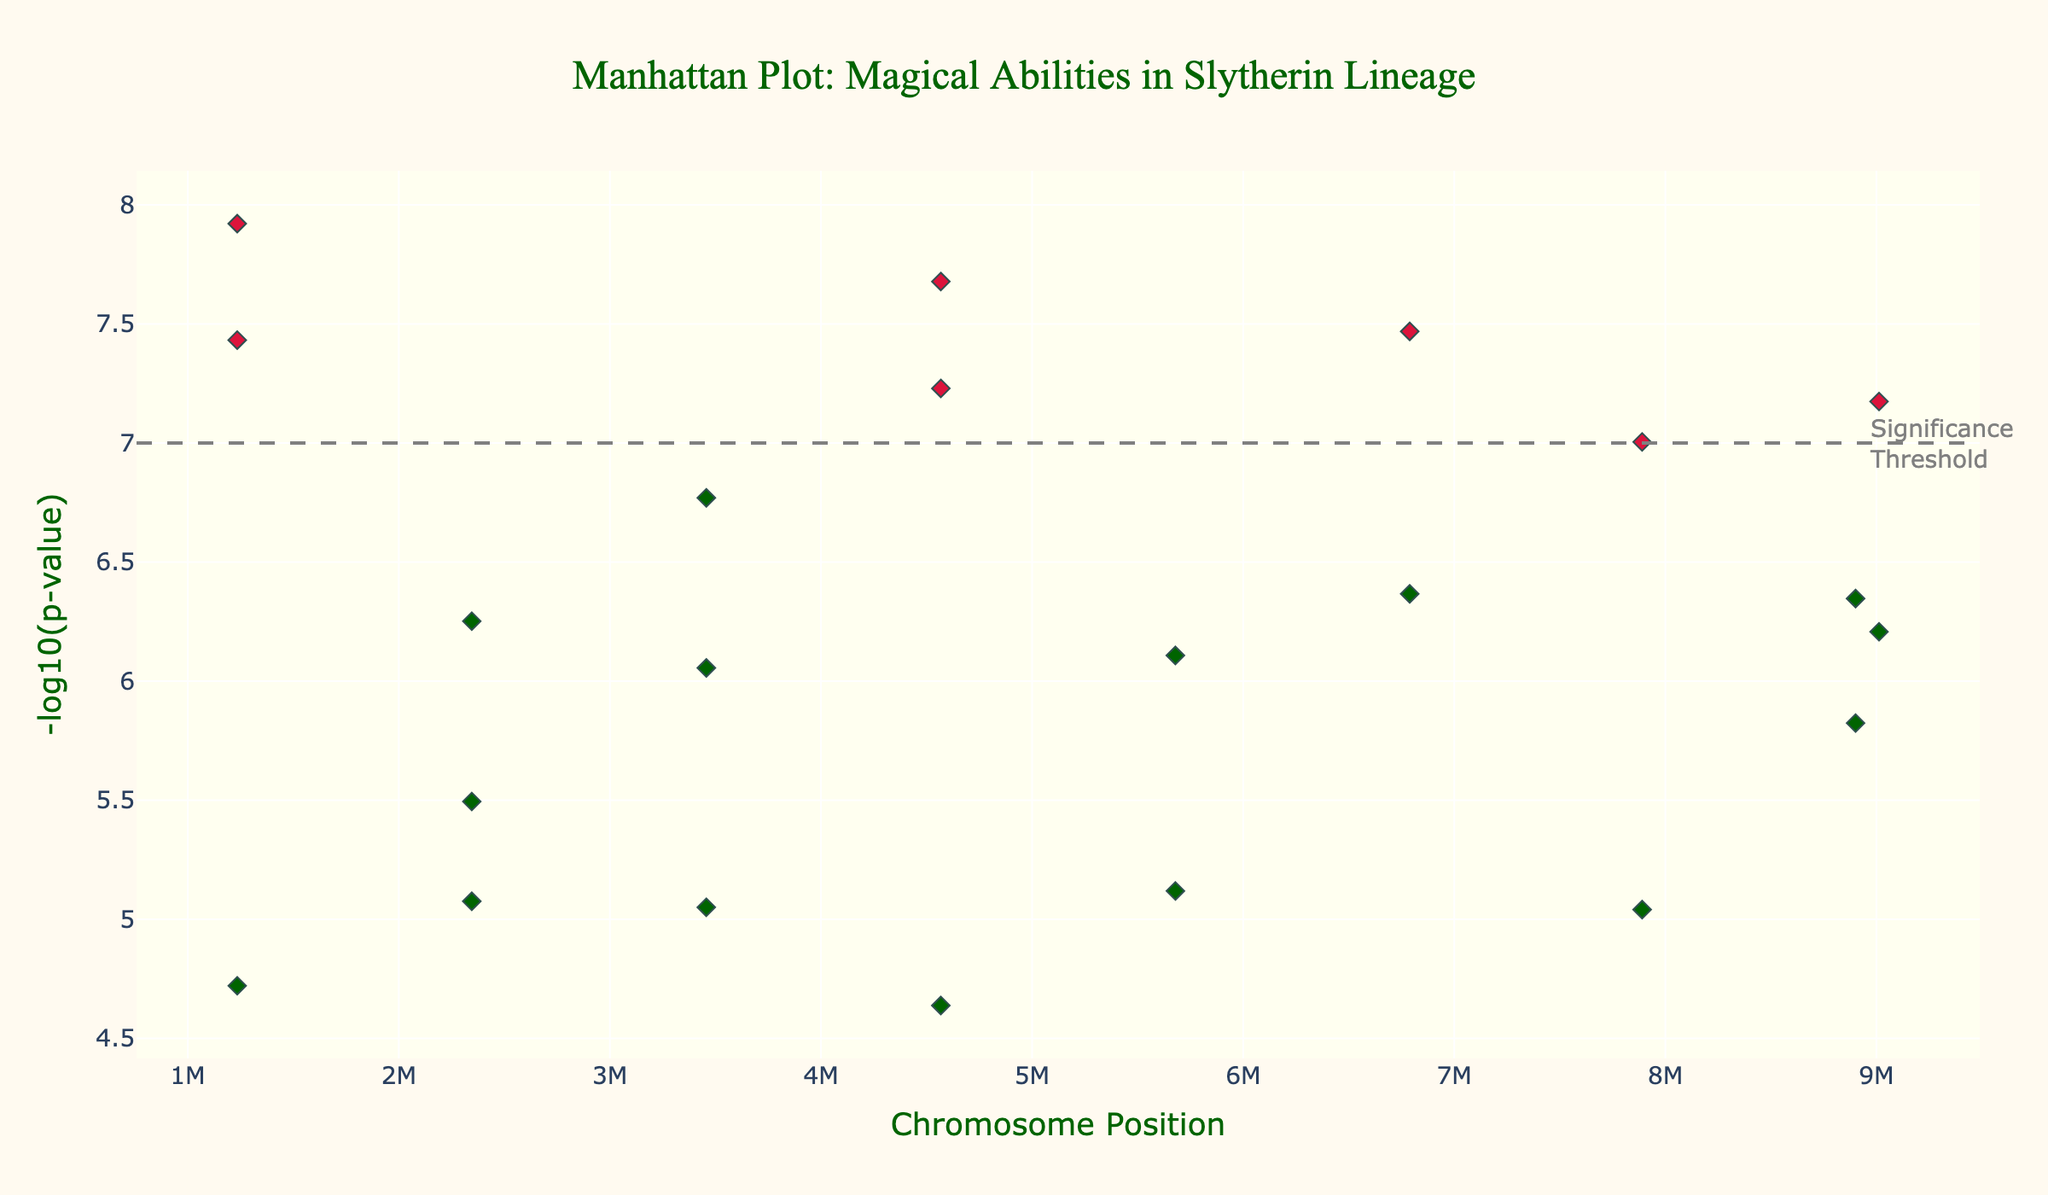What is the title of the Manhattan plot? The title of the Manhattan plot can be found at the top of the figure and usually provides a quick overview of what the plot is depicting. The title here says "Manhattan Plot: Magical Abilities in Slytherin Lineage."
Answer: Manhattan Plot: Magical Abilities in Slytherin Lineage Which chromosome has the gene associated with the highest -log10(p-value)? By looking at the y-axis, the gene with the highest -log10(p-value) value will be the highest point on the plot. The corresponding chromosome number of this point will provide the answer.
Answer: Chromosome 1 How many genes have a -log10(p-value) greater than the significance threshold (7)? Genes with -log10(p-values) greater than 7 will be the points above the horizontal dash line at y=7. Counting these points gives the number of genes over the threshold.
Answer: 7 genes What are the traits associated with the genes that have a -log10(p-value) greater than 7? The traits can be identified by hovering over the points above the significance threshold in the plot or reading from the legend if available. The traits are Parseltongue, Occlumency proficiency, Potions expertise, Memory charm resistance, Pure-blood lineage markers, Charm casting prowess, and Sorting Hat influence.
Answer: Parseltongue, Occlumency proficiency, Potions expertise, Memory charm resistance, Pure-blood lineage markers, Charm casting prowess, Sorting Hat influence Which gene and trait are associated with Chromosome 4? To find the gene and trait related to Chromosome 4, locate the data points associated with Chromosome 4 and inspect their hover text or check the legend if available. In this case, the gene is DARKARTS4 and the trait is Dark magic aptitude.
Answer: DARKARTS4, Dark magic aptitude What is the chromosomal position of the gene with the highest -log10(p-value)? The highest -log10(p-value) point on the plot indicates the gene with the highest significance. Check the x-axis value (position) where this point is located. The highest point corresponds to Chromosome 1 at position 1234567.
Answer: 1234567 Compare the -log10(p-value) of genes on Chromosome 5 and 8. Which gene has a higher value? To compare, find the -log10(p)value of the genes on Chromosome 5 and 8. Chromosome 5 has a value associated with Cunning and ambition, and Chromosome 8 with Blonde hair inheritance. The gene on Chromosome 8 has a higher -log10(p-value) based on the position within the plot.
Answer: Blonde hair inheritance How many chromosomes have at least one gene with a -log10(p-value) greater than 6? By visually inspecting the plot, count the number of chromosomes with points positioned above the -log10(p-value) of 6 on the y-axis. These chromosomes are the ones having at least one -log10(p-value) higher than 6.
Answer: 13 chromosomes What is the significance threshold for -log10(p-value) in the plot? The significance threshold is indicated by a horizontal dashed line in the Manhattan plot, which in this case is at -log10(p-value) of 7.
Answer: 7 